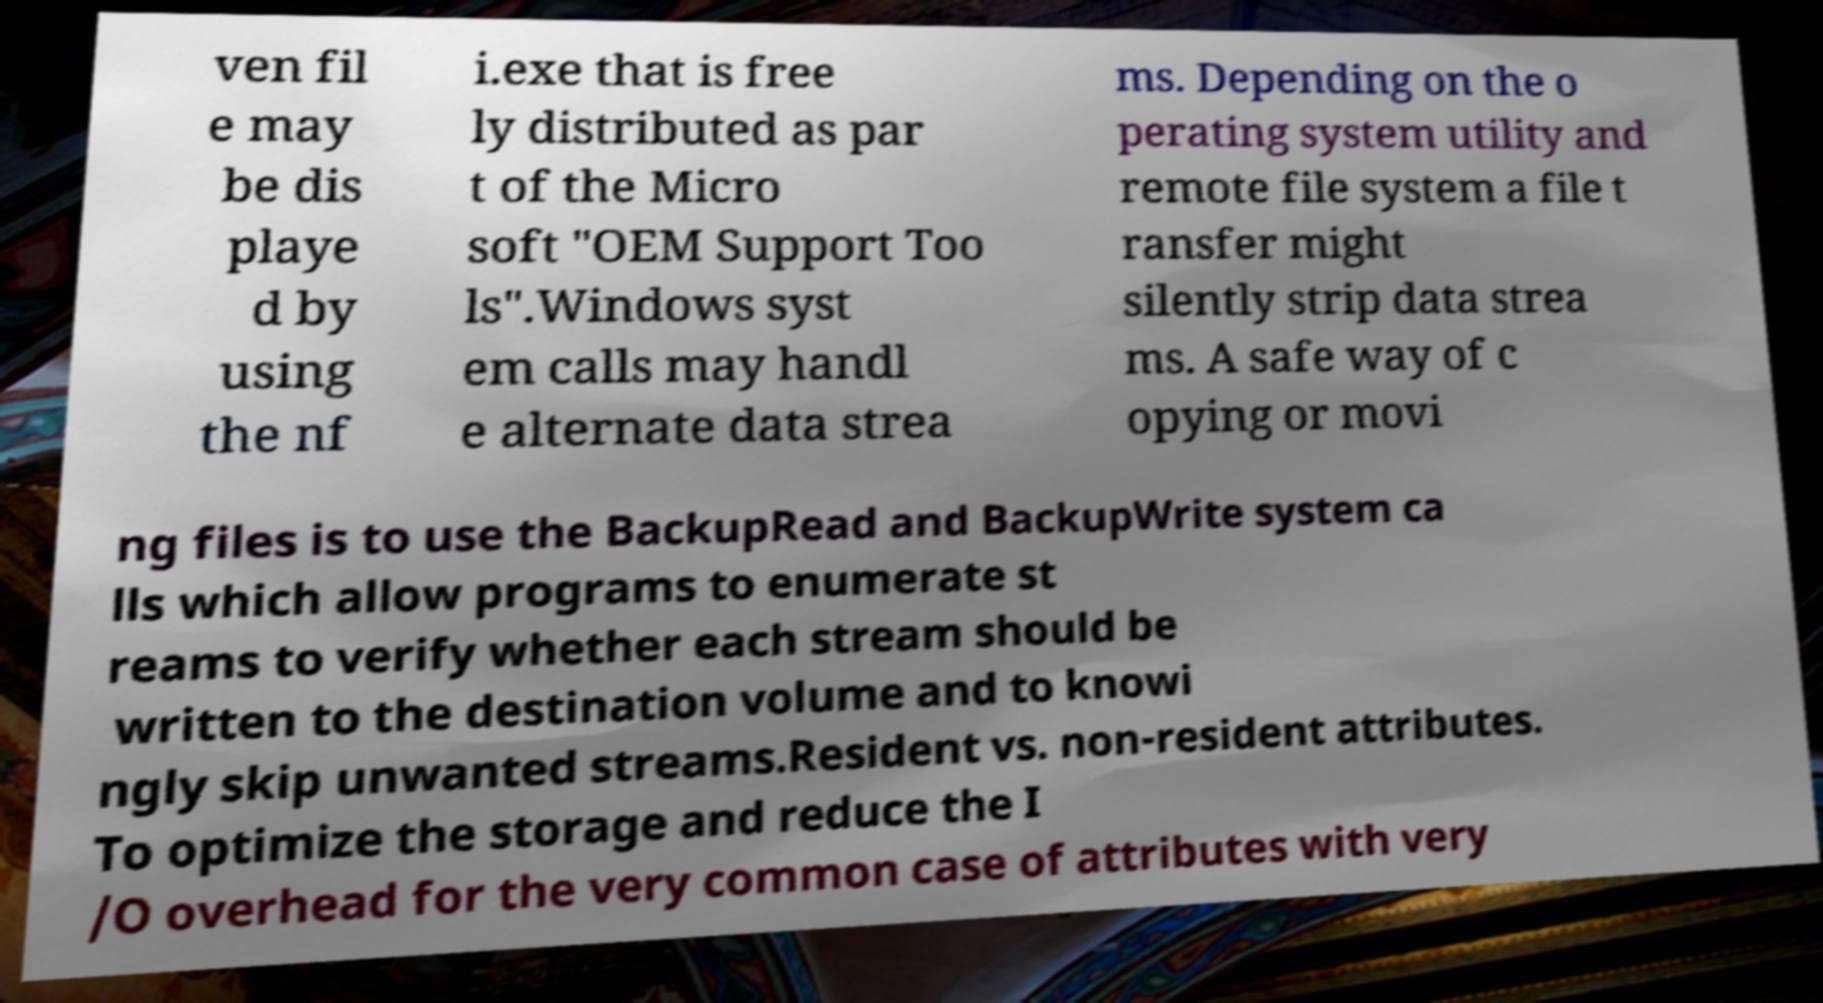What messages or text are displayed in this image? I need them in a readable, typed format. ven fil e may be dis playe d by using the nf i.exe that is free ly distributed as par t of the Micro soft "OEM Support Too ls".Windows syst em calls may handl e alternate data strea ms. Depending on the o perating system utility and remote file system a file t ransfer might silently strip data strea ms. A safe way of c opying or movi ng files is to use the BackupRead and BackupWrite system ca lls which allow programs to enumerate st reams to verify whether each stream should be written to the destination volume and to knowi ngly skip unwanted streams.Resident vs. non-resident attributes. To optimize the storage and reduce the I /O overhead for the very common case of attributes with very 